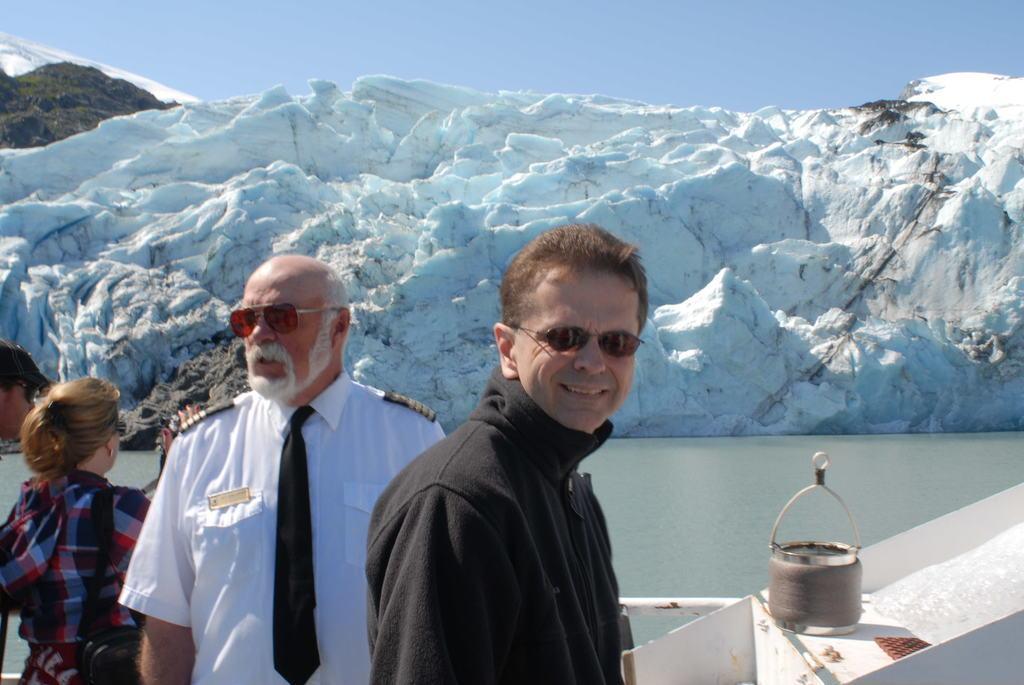In one or two sentences, can you explain what this image depicts? In the foreground of the image there are people. In the background of the image there is ice mountain. In the center of the image there is water. 